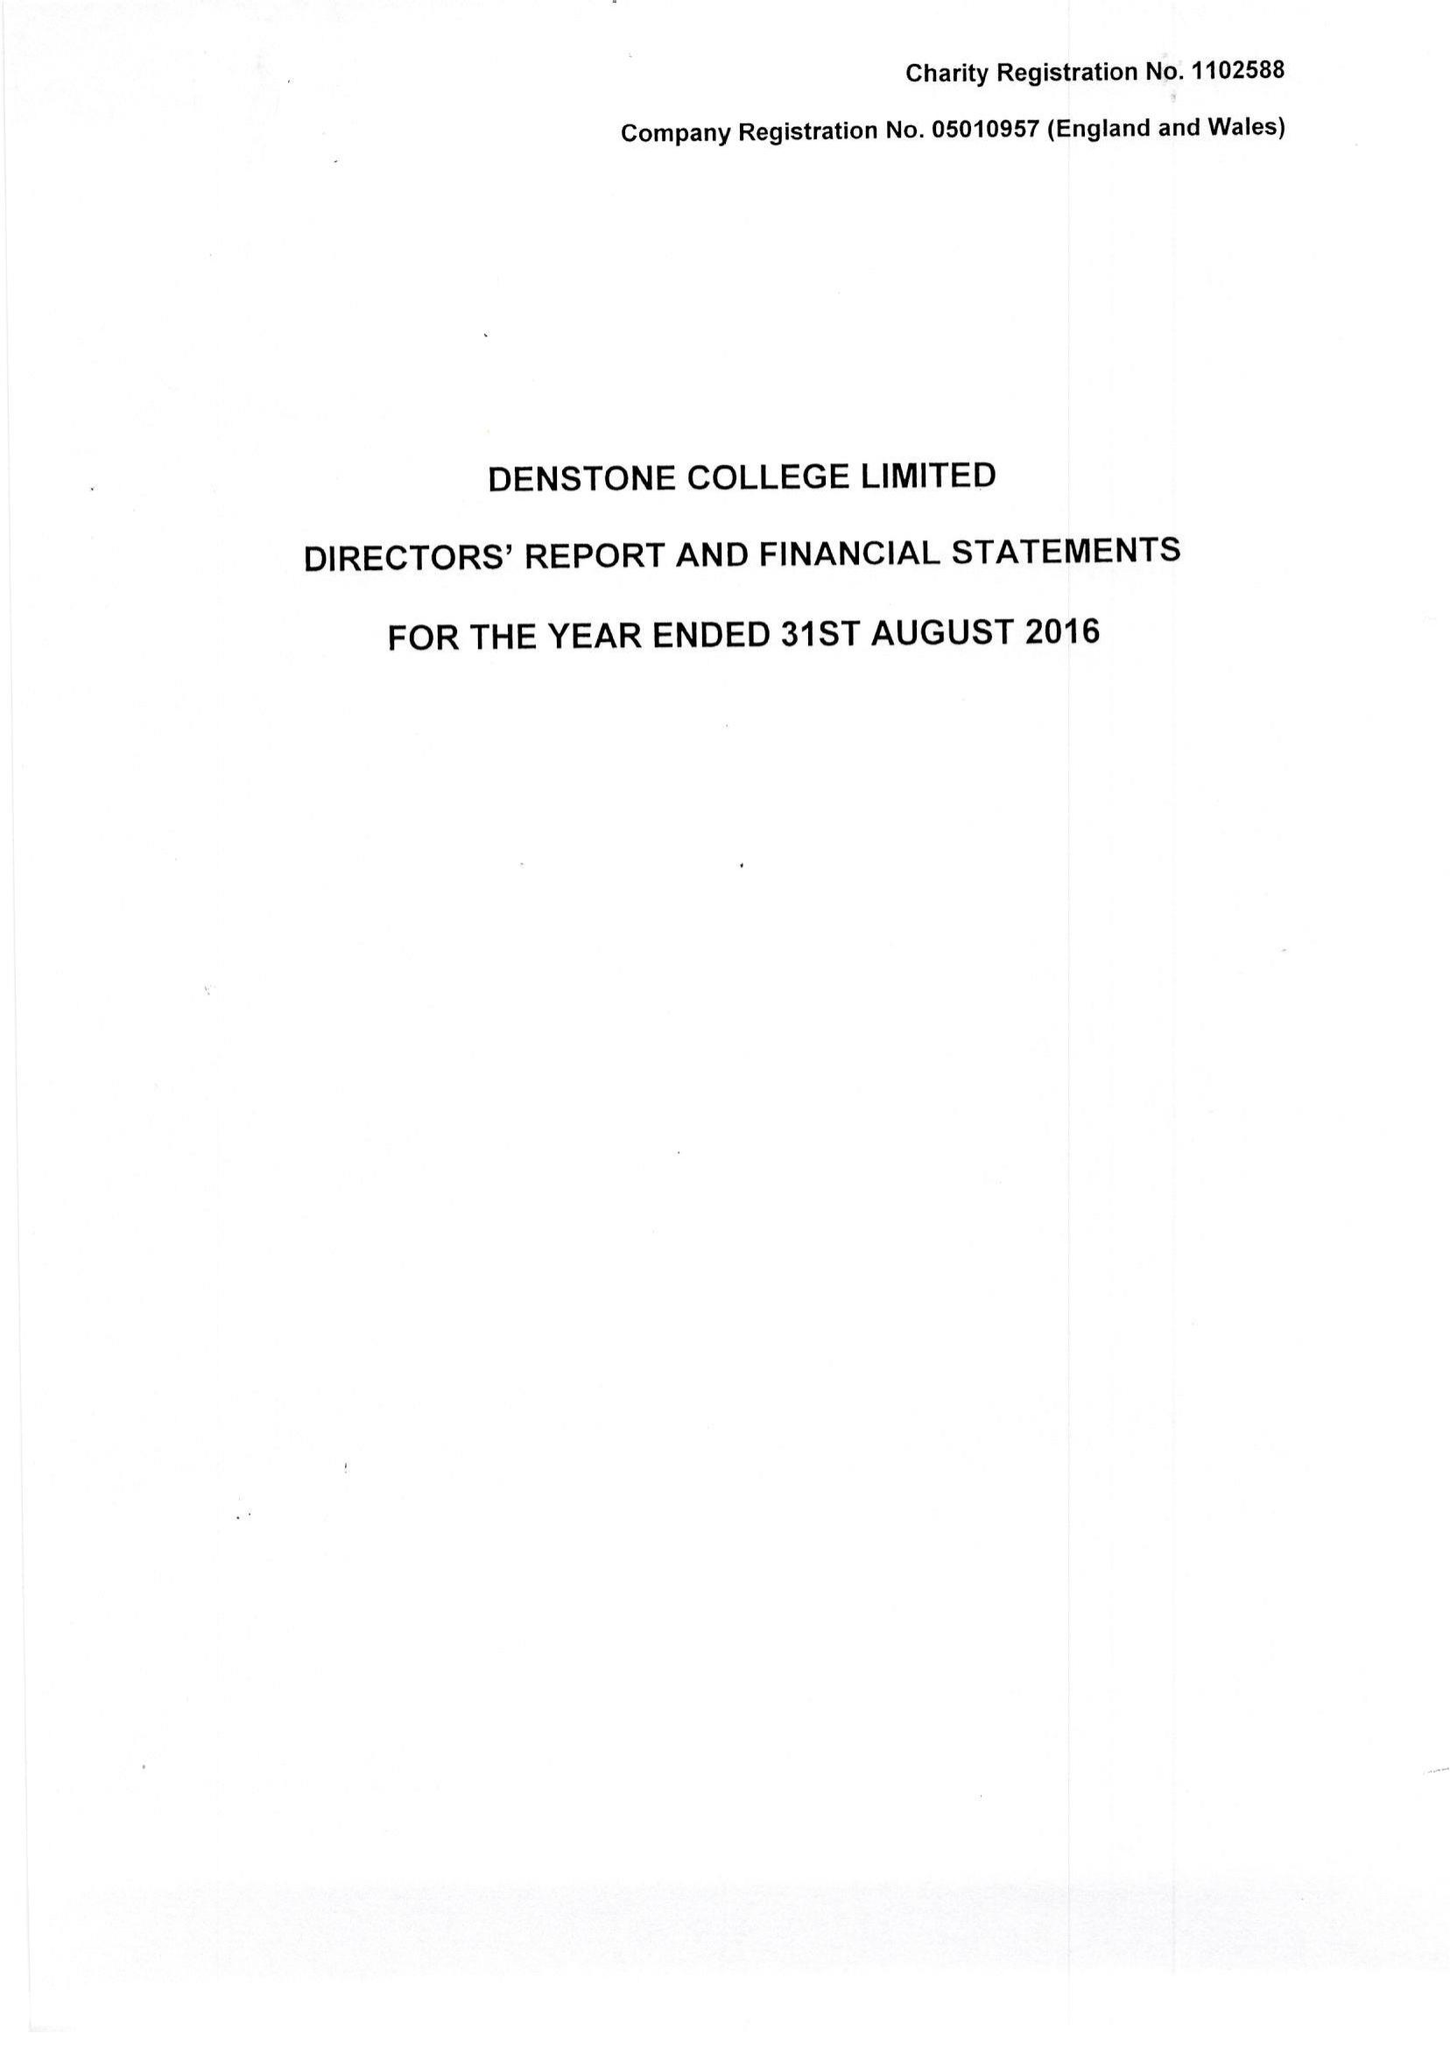What is the value for the charity_name?
Answer the question using a single word or phrase. Denstone College Ltd. 